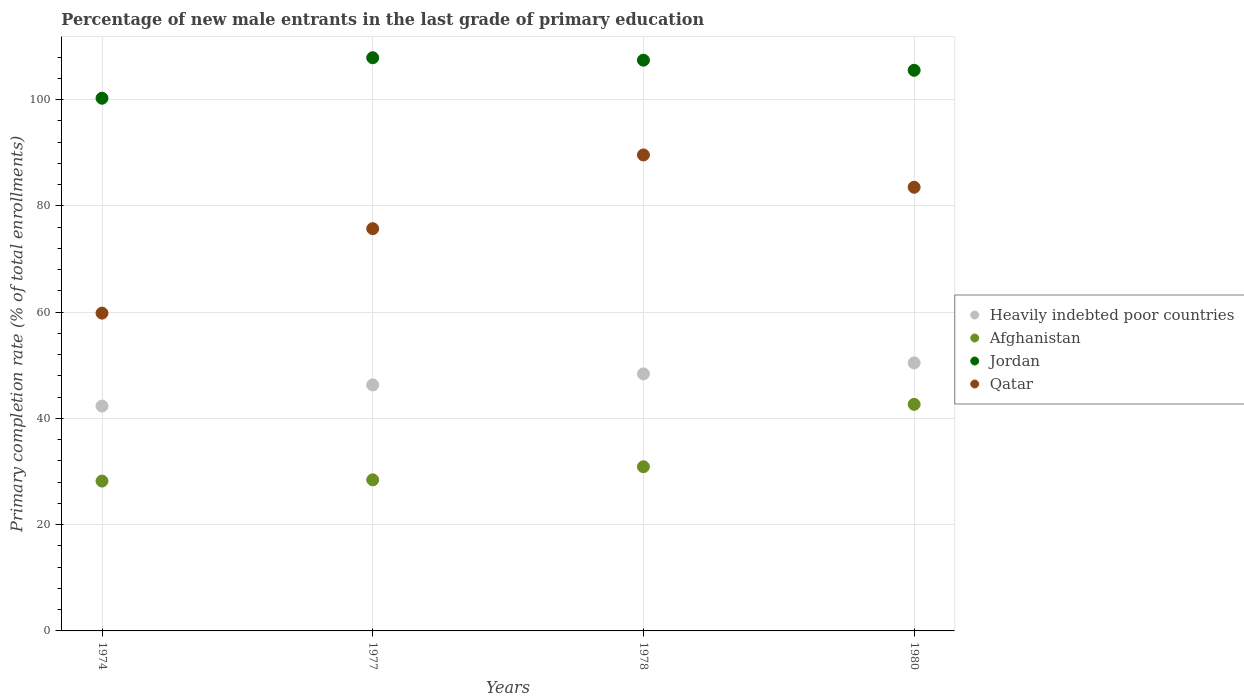What is the percentage of new male entrants in Afghanistan in 1974?
Ensure brevity in your answer.  28.21. Across all years, what is the maximum percentage of new male entrants in Heavily indebted poor countries?
Provide a succinct answer. 50.45. Across all years, what is the minimum percentage of new male entrants in Jordan?
Keep it short and to the point. 100.28. In which year was the percentage of new male entrants in Qatar maximum?
Provide a short and direct response. 1978. In which year was the percentage of new male entrants in Jordan minimum?
Ensure brevity in your answer.  1974. What is the total percentage of new male entrants in Heavily indebted poor countries in the graph?
Provide a succinct answer. 187.47. What is the difference between the percentage of new male entrants in Qatar in 1974 and that in 1980?
Offer a very short reply. -23.69. What is the difference between the percentage of new male entrants in Jordan in 1978 and the percentage of new male entrants in Qatar in 1980?
Offer a terse response. 23.92. What is the average percentage of new male entrants in Jordan per year?
Provide a succinct answer. 105.29. In the year 1974, what is the difference between the percentage of new male entrants in Qatar and percentage of new male entrants in Afghanistan?
Ensure brevity in your answer.  31.61. In how many years, is the percentage of new male entrants in Heavily indebted poor countries greater than 92 %?
Provide a succinct answer. 0. What is the ratio of the percentage of new male entrants in Qatar in 1978 to that in 1980?
Give a very brief answer. 1.07. Is the percentage of new male entrants in Heavily indebted poor countries in 1978 less than that in 1980?
Ensure brevity in your answer.  Yes. What is the difference between the highest and the second highest percentage of new male entrants in Afghanistan?
Make the answer very short. 11.75. What is the difference between the highest and the lowest percentage of new male entrants in Qatar?
Your answer should be compact. 29.78. Is it the case that in every year, the sum of the percentage of new male entrants in Afghanistan and percentage of new male entrants in Jordan  is greater than the percentage of new male entrants in Heavily indebted poor countries?
Your answer should be compact. Yes. Is the percentage of new male entrants in Qatar strictly greater than the percentage of new male entrants in Heavily indebted poor countries over the years?
Provide a short and direct response. Yes. Is the percentage of new male entrants in Heavily indebted poor countries strictly less than the percentage of new male entrants in Jordan over the years?
Your response must be concise. Yes. How many dotlines are there?
Your answer should be very brief. 4. How many years are there in the graph?
Provide a short and direct response. 4. What is the difference between two consecutive major ticks on the Y-axis?
Your answer should be very brief. 20. Does the graph contain any zero values?
Offer a terse response. No. How many legend labels are there?
Your answer should be very brief. 4. What is the title of the graph?
Your answer should be compact. Percentage of new male entrants in the last grade of primary education. Does "Rwanda" appear as one of the legend labels in the graph?
Make the answer very short. No. What is the label or title of the X-axis?
Provide a short and direct response. Years. What is the label or title of the Y-axis?
Your answer should be very brief. Primary completion rate (% of total enrollments). What is the Primary completion rate (% of total enrollments) in Heavily indebted poor countries in 1974?
Provide a short and direct response. 42.32. What is the Primary completion rate (% of total enrollments) of Afghanistan in 1974?
Provide a succinct answer. 28.21. What is the Primary completion rate (% of total enrollments) in Jordan in 1974?
Provide a succinct answer. 100.28. What is the Primary completion rate (% of total enrollments) in Qatar in 1974?
Give a very brief answer. 59.82. What is the Primary completion rate (% of total enrollments) in Heavily indebted poor countries in 1977?
Offer a terse response. 46.31. What is the Primary completion rate (% of total enrollments) of Afghanistan in 1977?
Offer a terse response. 28.44. What is the Primary completion rate (% of total enrollments) in Jordan in 1977?
Your answer should be very brief. 107.9. What is the Primary completion rate (% of total enrollments) in Qatar in 1977?
Ensure brevity in your answer.  75.72. What is the Primary completion rate (% of total enrollments) of Heavily indebted poor countries in 1978?
Provide a succinct answer. 48.39. What is the Primary completion rate (% of total enrollments) in Afghanistan in 1978?
Provide a short and direct response. 30.91. What is the Primary completion rate (% of total enrollments) of Jordan in 1978?
Provide a short and direct response. 107.44. What is the Primary completion rate (% of total enrollments) in Qatar in 1978?
Make the answer very short. 89.6. What is the Primary completion rate (% of total enrollments) of Heavily indebted poor countries in 1980?
Keep it short and to the point. 50.45. What is the Primary completion rate (% of total enrollments) of Afghanistan in 1980?
Offer a terse response. 42.65. What is the Primary completion rate (% of total enrollments) in Jordan in 1980?
Offer a very short reply. 105.53. What is the Primary completion rate (% of total enrollments) of Qatar in 1980?
Your answer should be compact. 83.52. Across all years, what is the maximum Primary completion rate (% of total enrollments) in Heavily indebted poor countries?
Provide a succinct answer. 50.45. Across all years, what is the maximum Primary completion rate (% of total enrollments) in Afghanistan?
Your answer should be compact. 42.65. Across all years, what is the maximum Primary completion rate (% of total enrollments) in Jordan?
Provide a short and direct response. 107.9. Across all years, what is the maximum Primary completion rate (% of total enrollments) in Qatar?
Your answer should be very brief. 89.6. Across all years, what is the minimum Primary completion rate (% of total enrollments) in Heavily indebted poor countries?
Your response must be concise. 42.32. Across all years, what is the minimum Primary completion rate (% of total enrollments) in Afghanistan?
Provide a succinct answer. 28.21. Across all years, what is the minimum Primary completion rate (% of total enrollments) in Jordan?
Ensure brevity in your answer.  100.28. Across all years, what is the minimum Primary completion rate (% of total enrollments) of Qatar?
Provide a succinct answer. 59.82. What is the total Primary completion rate (% of total enrollments) of Heavily indebted poor countries in the graph?
Your response must be concise. 187.47. What is the total Primary completion rate (% of total enrollments) in Afghanistan in the graph?
Your response must be concise. 130.2. What is the total Primary completion rate (% of total enrollments) in Jordan in the graph?
Your response must be concise. 421.14. What is the total Primary completion rate (% of total enrollments) in Qatar in the graph?
Your response must be concise. 308.66. What is the difference between the Primary completion rate (% of total enrollments) of Heavily indebted poor countries in 1974 and that in 1977?
Keep it short and to the point. -3.99. What is the difference between the Primary completion rate (% of total enrollments) of Afghanistan in 1974 and that in 1977?
Your answer should be very brief. -0.23. What is the difference between the Primary completion rate (% of total enrollments) in Jordan in 1974 and that in 1977?
Provide a short and direct response. -7.62. What is the difference between the Primary completion rate (% of total enrollments) of Qatar in 1974 and that in 1977?
Your answer should be compact. -15.9. What is the difference between the Primary completion rate (% of total enrollments) of Heavily indebted poor countries in 1974 and that in 1978?
Make the answer very short. -6.06. What is the difference between the Primary completion rate (% of total enrollments) in Afghanistan in 1974 and that in 1978?
Your response must be concise. -2.7. What is the difference between the Primary completion rate (% of total enrollments) in Jordan in 1974 and that in 1978?
Keep it short and to the point. -7.16. What is the difference between the Primary completion rate (% of total enrollments) of Qatar in 1974 and that in 1978?
Provide a short and direct response. -29.78. What is the difference between the Primary completion rate (% of total enrollments) in Heavily indebted poor countries in 1974 and that in 1980?
Keep it short and to the point. -8.13. What is the difference between the Primary completion rate (% of total enrollments) in Afghanistan in 1974 and that in 1980?
Give a very brief answer. -14.44. What is the difference between the Primary completion rate (% of total enrollments) in Jordan in 1974 and that in 1980?
Your response must be concise. -5.26. What is the difference between the Primary completion rate (% of total enrollments) in Qatar in 1974 and that in 1980?
Ensure brevity in your answer.  -23.69. What is the difference between the Primary completion rate (% of total enrollments) in Heavily indebted poor countries in 1977 and that in 1978?
Your response must be concise. -2.07. What is the difference between the Primary completion rate (% of total enrollments) of Afghanistan in 1977 and that in 1978?
Keep it short and to the point. -2.47. What is the difference between the Primary completion rate (% of total enrollments) in Jordan in 1977 and that in 1978?
Provide a short and direct response. 0.46. What is the difference between the Primary completion rate (% of total enrollments) in Qatar in 1977 and that in 1978?
Keep it short and to the point. -13.88. What is the difference between the Primary completion rate (% of total enrollments) in Heavily indebted poor countries in 1977 and that in 1980?
Offer a terse response. -4.14. What is the difference between the Primary completion rate (% of total enrollments) of Afghanistan in 1977 and that in 1980?
Your response must be concise. -14.21. What is the difference between the Primary completion rate (% of total enrollments) of Jordan in 1977 and that in 1980?
Provide a succinct answer. 2.36. What is the difference between the Primary completion rate (% of total enrollments) in Qatar in 1977 and that in 1980?
Offer a very short reply. -7.79. What is the difference between the Primary completion rate (% of total enrollments) in Heavily indebted poor countries in 1978 and that in 1980?
Provide a succinct answer. -2.06. What is the difference between the Primary completion rate (% of total enrollments) of Afghanistan in 1978 and that in 1980?
Offer a very short reply. -11.75. What is the difference between the Primary completion rate (% of total enrollments) of Jordan in 1978 and that in 1980?
Keep it short and to the point. 1.9. What is the difference between the Primary completion rate (% of total enrollments) in Qatar in 1978 and that in 1980?
Provide a short and direct response. 6.08. What is the difference between the Primary completion rate (% of total enrollments) in Heavily indebted poor countries in 1974 and the Primary completion rate (% of total enrollments) in Afghanistan in 1977?
Give a very brief answer. 13.89. What is the difference between the Primary completion rate (% of total enrollments) of Heavily indebted poor countries in 1974 and the Primary completion rate (% of total enrollments) of Jordan in 1977?
Offer a very short reply. -65.57. What is the difference between the Primary completion rate (% of total enrollments) in Heavily indebted poor countries in 1974 and the Primary completion rate (% of total enrollments) in Qatar in 1977?
Keep it short and to the point. -33.4. What is the difference between the Primary completion rate (% of total enrollments) of Afghanistan in 1974 and the Primary completion rate (% of total enrollments) of Jordan in 1977?
Ensure brevity in your answer.  -79.69. What is the difference between the Primary completion rate (% of total enrollments) of Afghanistan in 1974 and the Primary completion rate (% of total enrollments) of Qatar in 1977?
Give a very brief answer. -47.51. What is the difference between the Primary completion rate (% of total enrollments) of Jordan in 1974 and the Primary completion rate (% of total enrollments) of Qatar in 1977?
Offer a terse response. 24.55. What is the difference between the Primary completion rate (% of total enrollments) in Heavily indebted poor countries in 1974 and the Primary completion rate (% of total enrollments) in Afghanistan in 1978?
Provide a succinct answer. 11.42. What is the difference between the Primary completion rate (% of total enrollments) in Heavily indebted poor countries in 1974 and the Primary completion rate (% of total enrollments) in Jordan in 1978?
Your answer should be compact. -65.11. What is the difference between the Primary completion rate (% of total enrollments) in Heavily indebted poor countries in 1974 and the Primary completion rate (% of total enrollments) in Qatar in 1978?
Offer a very short reply. -47.27. What is the difference between the Primary completion rate (% of total enrollments) in Afghanistan in 1974 and the Primary completion rate (% of total enrollments) in Jordan in 1978?
Offer a terse response. -79.23. What is the difference between the Primary completion rate (% of total enrollments) in Afghanistan in 1974 and the Primary completion rate (% of total enrollments) in Qatar in 1978?
Provide a short and direct response. -61.39. What is the difference between the Primary completion rate (% of total enrollments) in Jordan in 1974 and the Primary completion rate (% of total enrollments) in Qatar in 1978?
Your response must be concise. 10.68. What is the difference between the Primary completion rate (% of total enrollments) of Heavily indebted poor countries in 1974 and the Primary completion rate (% of total enrollments) of Afghanistan in 1980?
Offer a very short reply. -0.33. What is the difference between the Primary completion rate (% of total enrollments) in Heavily indebted poor countries in 1974 and the Primary completion rate (% of total enrollments) in Jordan in 1980?
Your answer should be very brief. -63.21. What is the difference between the Primary completion rate (% of total enrollments) of Heavily indebted poor countries in 1974 and the Primary completion rate (% of total enrollments) of Qatar in 1980?
Give a very brief answer. -41.19. What is the difference between the Primary completion rate (% of total enrollments) in Afghanistan in 1974 and the Primary completion rate (% of total enrollments) in Jordan in 1980?
Offer a terse response. -77.33. What is the difference between the Primary completion rate (% of total enrollments) in Afghanistan in 1974 and the Primary completion rate (% of total enrollments) in Qatar in 1980?
Provide a succinct answer. -55.31. What is the difference between the Primary completion rate (% of total enrollments) in Jordan in 1974 and the Primary completion rate (% of total enrollments) in Qatar in 1980?
Keep it short and to the point. 16.76. What is the difference between the Primary completion rate (% of total enrollments) of Heavily indebted poor countries in 1977 and the Primary completion rate (% of total enrollments) of Afghanistan in 1978?
Give a very brief answer. 15.41. What is the difference between the Primary completion rate (% of total enrollments) of Heavily indebted poor countries in 1977 and the Primary completion rate (% of total enrollments) of Jordan in 1978?
Offer a terse response. -61.12. What is the difference between the Primary completion rate (% of total enrollments) in Heavily indebted poor countries in 1977 and the Primary completion rate (% of total enrollments) in Qatar in 1978?
Give a very brief answer. -43.29. What is the difference between the Primary completion rate (% of total enrollments) in Afghanistan in 1977 and the Primary completion rate (% of total enrollments) in Jordan in 1978?
Offer a very short reply. -79. What is the difference between the Primary completion rate (% of total enrollments) of Afghanistan in 1977 and the Primary completion rate (% of total enrollments) of Qatar in 1978?
Provide a succinct answer. -61.16. What is the difference between the Primary completion rate (% of total enrollments) of Jordan in 1977 and the Primary completion rate (% of total enrollments) of Qatar in 1978?
Give a very brief answer. 18.3. What is the difference between the Primary completion rate (% of total enrollments) in Heavily indebted poor countries in 1977 and the Primary completion rate (% of total enrollments) in Afghanistan in 1980?
Provide a succinct answer. 3.66. What is the difference between the Primary completion rate (% of total enrollments) of Heavily indebted poor countries in 1977 and the Primary completion rate (% of total enrollments) of Jordan in 1980?
Provide a succinct answer. -59.22. What is the difference between the Primary completion rate (% of total enrollments) of Heavily indebted poor countries in 1977 and the Primary completion rate (% of total enrollments) of Qatar in 1980?
Keep it short and to the point. -37.2. What is the difference between the Primary completion rate (% of total enrollments) of Afghanistan in 1977 and the Primary completion rate (% of total enrollments) of Jordan in 1980?
Your response must be concise. -77.1. What is the difference between the Primary completion rate (% of total enrollments) of Afghanistan in 1977 and the Primary completion rate (% of total enrollments) of Qatar in 1980?
Provide a short and direct response. -55.08. What is the difference between the Primary completion rate (% of total enrollments) of Jordan in 1977 and the Primary completion rate (% of total enrollments) of Qatar in 1980?
Provide a succinct answer. 24.38. What is the difference between the Primary completion rate (% of total enrollments) of Heavily indebted poor countries in 1978 and the Primary completion rate (% of total enrollments) of Afghanistan in 1980?
Ensure brevity in your answer.  5.74. What is the difference between the Primary completion rate (% of total enrollments) in Heavily indebted poor countries in 1978 and the Primary completion rate (% of total enrollments) in Jordan in 1980?
Your answer should be very brief. -57.15. What is the difference between the Primary completion rate (% of total enrollments) of Heavily indebted poor countries in 1978 and the Primary completion rate (% of total enrollments) of Qatar in 1980?
Give a very brief answer. -35.13. What is the difference between the Primary completion rate (% of total enrollments) in Afghanistan in 1978 and the Primary completion rate (% of total enrollments) in Jordan in 1980?
Provide a short and direct response. -74.63. What is the difference between the Primary completion rate (% of total enrollments) in Afghanistan in 1978 and the Primary completion rate (% of total enrollments) in Qatar in 1980?
Your answer should be very brief. -52.61. What is the difference between the Primary completion rate (% of total enrollments) of Jordan in 1978 and the Primary completion rate (% of total enrollments) of Qatar in 1980?
Offer a terse response. 23.92. What is the average Primary completion rate (% of total enrollments) in Heavily indebted poor countries per year?
Ensure brevity in your answer.  46.87. What is the average Primary completion rate (% of total enrollments) of Afghanistan per year?
Your response must be concise. 32.55. What is the average Primary completion rate (% of total enrollments) of Jordan per year?
Provide a short and direct response. 105.29. What is the average Primary completion rate (% of total enrollments) of Qatar per year?
Provide a succinct answer. 77.17. In the year 1974, what is the difference between the Primary completion rate (% of total enrollments) in Heavily indebted poor countries and Primary completion rate (% of total enrollments) in Afghanistan?
Offer a terse response. 14.12. In the year 1974, what is the difference between the Primary completion rate (% of total enrollments) in Heavily indebted poor countries and Primary completion rate (% of total enrollments) in Jordan?
Keep it short and to the point. -57.95. In the year 1974, what is the difference between the Primary completion rate (% of total enrollments) of Heavily indebted poor countries and Primary completion rate (% of total enrollments) of Qatar?
Provide a succinct answer. -17.5. In the year 1974, what is the difference between the Primary completion rate (% of total enrollments) of Afghanistan and Primary completion rate (% of total enrollments) of Jordan?
Make the answer very short. -72.07. In the year 1974, what is the difference between the Primary completion rate (% of total enrollments) of Afghanistan and Primary completion rate (% of total enrollments) of Qatar?
Ensure brevity in your answer.  -31.61. In the year 1974, what is the difference between the Primary completion rate (% of total enrollments) of Jordan and Primary completion rate (% of total enrollments) of Qatar?
Make the answer very short. 40.45. In the year 1977, what is the difference between the Primary completion rate (% of total enrollments) in Heavily indebted poor countries and Primary completion rate (% of total enrollments) in Afghanistan?
Give a very brief answer. 17.87. In the year 1977, what is the difference between the Primary completion rate (% of total enrollments) in Heavily indebted poor countries and Primary completion rate (% of total enrollments) in Jordan?
Provide a succinct answer. -61.58. In the year 1977, what is the difference between the Primary completion rate (% of total enrollments) of Heavily indebted poor countries and Primary completion rate (% of total enrollments) of Qatar?
Your response must be concise. -29.41. In the year 1977, what is the difference between the Primary completion rate (% of total enrollments) in Afghanistan and Primary completion rate (% of total enrollments) in Jordan?
Make the answer very short. -79.46. In the year 1977, what is the difference between the Primary completion rate (% of total enrollments) in Afghanistan and Primary completion rate (% of total enrollments) in Qatar?
Offer a terse response. -47.28. In the year 1977, what is the difference between the Primary completion rate (% of total enrollments) in Jordan and Primary completion rate (% of total enrollments) in Qatar?
Your response must be concise. 32.17. In the year 1978, what is the difference between the Primary completion rate (% of total enrollments) of Heavily indebted poor countries and Primary completion rate (% of total enrollments) of Afghanistan?
Provide a succinct answer. 17.48. In the year 1978, what is the difference between the Primary completion rate (% of total enrollments) of Heavily indebted poor countries and Primary completion rate (% of total enrollments) of Jordan?
Keep it short and to the point. -59.05. In the year 1978, what is the difference between the Primary completion rate (% of total enrollments) of Heavily indebted poor countries and Primary completion rate (% of total enrollments) of Qatar?
Provide a succinct answer. -41.21. In the year 1978, what is the difference between the Primary completion rate (% of total enrollments) in Afghanistan and Primary completion rate (% of total enrollments) in Jordan?
Offer a terse response. -76.53. In the year 1978, what is the difference between the Primary completion rate (% of total enrollments) of Afghanistan and Primary completion rate (% of total enrollments) of Qatar?
Make the answer very short. -58.69. In the year 1978, what is the difference between the Primary completion rate (% of total enrollments) of Jordan and Primary completion rate (% of total enrollments) of Qatar?
Offer a terse response. 17.84. In the year 1980, what is the difference between the Primary completion rate (% of total enrollments) of Heavily indebted poor countries and Primary completion rate (% of total enrollments) of Afghanistan?
Make the answer very short. 7.8. In the year 1980, what is the difference between the Primary completion rate (% of total enrollments) in Heavily indebted poor countries and Primary completion rate (% of total enrollments) in Jordan?
Your answer should be compact. -55.08. In the year 1980, what is the difference between the Primary completion rate (% of total enrollments) in Heavily indebted poor countries and Primary completion rate (% of total enrollments) in Qatar?
Make the answer very short. -33.06. In the year 1980, what is the difference between the Primary completion rate (% of total enrollments) in Afghanistan and Primary completion rate (% of total enrollments) in Jordan?
Provide a short and direct response. -62.88. In the year 1980, what is the difference between the Primary completion rate (% of total enrollments) in Afghanistan and Primary completion rate (% of total enrollments) in Qatar?
Your response must be concise. -40.86. In the year 1980, what is the difference between the Primary completion rate (% of total enrollments) of Jordan and Primary completion rate (% of total enrollments) of Qatar?
Your answer should be very brief. 22.02. What is the ratio of the Primary completion rate (% of total enrollments) in Heavily indebted poor countries in 1974 to that in 1977?
Your answer should be very brief. 0.91. What is the ratio of the Primary completion rate (% of total enrollments) in Jordan in 1974 to that in 1977?
Offer a very short reply. 0.93. What is the ratio of the Primary completion rate (% of total enrollments) in Qatar in 1974 to that in 1977?
Provide a short and direct response. 0.79. What is the ratio of the Primary completion rate (% of total enrollments) of Heavily indebted poor countries in 1974 to that in 1978?
Offer a very short reply. 0.87. What is the ratio of the Primary completion rate (% of total enrollments) of Afghanistan in 1974 to that in 1978?
Your answer should be very brief. 0.91. What is the ratio of the Primary completion rate (% of total enrollments) in Jordan in 1974 to that in 1978?
Offer a very short reply. 0.93. What is the ratio of the Primary completion rate (% of total enrollments) in Qatar in 1974 to that in 1978?
Offer a very short reply. 0.67. What is the ratio of the Primary completion rate (% of total enrollments) of Heavily indebted poor countries in 1974 to that in 1980?
Make the answer very short. 0.84. What is the ratio of the Primary completion rate (% of total enrollments) of Afghanistan in 1974 to that in 1980?
Provide a short and direct response. 0.66. What is the ratio of the Primary completion rate (% of total enrollments) in Jordan in 1974 to that in 1980?
Your answer should be compact. 0.95. What is the ratio of the Primary completion rate (% of total enrollments) in Qatar in 1974 to that in 1980?
Give a very brief answer. 0.72. What is the ratio of the Primary completion rate (% of total enrollments) in Heavily indebted poor countries in 1977 to that in 1978?
Make the answer very short. 0.96. What is the ratio of the Primary completion rate (% of total enrollments) of Afghanistan in 1977 to that in 1978?
Your answer should be very brief. 0.92. What is the ratio of the Primary completion rate (% of total enrollments) in Qatar in 1977 to that in 1978?
Your response must be concise. 0.85. What is the ratio of the Primary completion rate (% of total enrollments) of Heavily indebted poor countries in 1977 to that in 1980?
Make the answer very short. 0.92. What is the ratio of the Primary completion rate (% of total enrollments) of Afghanistan in 1977 to that in 1980?
Keep it short and to the point. 0.67. What is the ratio of the Primary completion rate (% of total enrollments) in Jordan in 1977 to that in 1980?
Your answer should be compact. 1.02. What is the ratio of the Primary completion rate (% of total enrollments) of Qatar in 1977 to that in 1980?
Provide a succinct answer. 0.91. What is the ratio of the Primary completion rate (% of total enrollments) in Heavily indebted poor countries in 1978 to that in 1980?
Offer a very short reply. 0.96. What is the ratio of the Primary completion rate (% of total enrollments) of Afghanistan in 1978 to that in 1980?
Your answer should be compact. 0.72. What is the ratio of the Primary completion rate (% of total enrollments) in Qatar in 1978 to that in 1980?
Ensure brevity in your answer.  1.07. What is the difference between the highest and the second highest Primary completion rate (% of total enrollments) in Heavily indebted poor countries?
Provide a short and direct response. 2.06. What is the difference between the highest and the second highest Primary completion rate (% of total enrollments) of Afghanistan?
Your answer should be compact. 11.75. What is the difference between the highest and the second highest Primary completion rate (% of total enrollments) of Jordan?
Provide a short and direct response. 0.46. What is the difference between the highest and the second highest Primary completion rate (% of total enrollments) in Qatar?
Your response must be concise. 6.08. What is the difference between the highest and the lowest Primary completion rate (% of total enrollments) of Heavily indebted poor countries?
Your answer should be very brief. 8.13. What is the difference between the highest and the lowest Primary completion rate (% of total enrollments) of Afghanistan?
Make the answer very short. 14.44. What is the difference between the highest and the lowest Primary completion rate (% of total enrollments) of Jordan?
Ensure brevity in your answer.  7.62. What is the difference between the highest and the lowest Primary completion rate (% of total enrollments) in Qatar?
Provide a succinct answer. 29.78. 